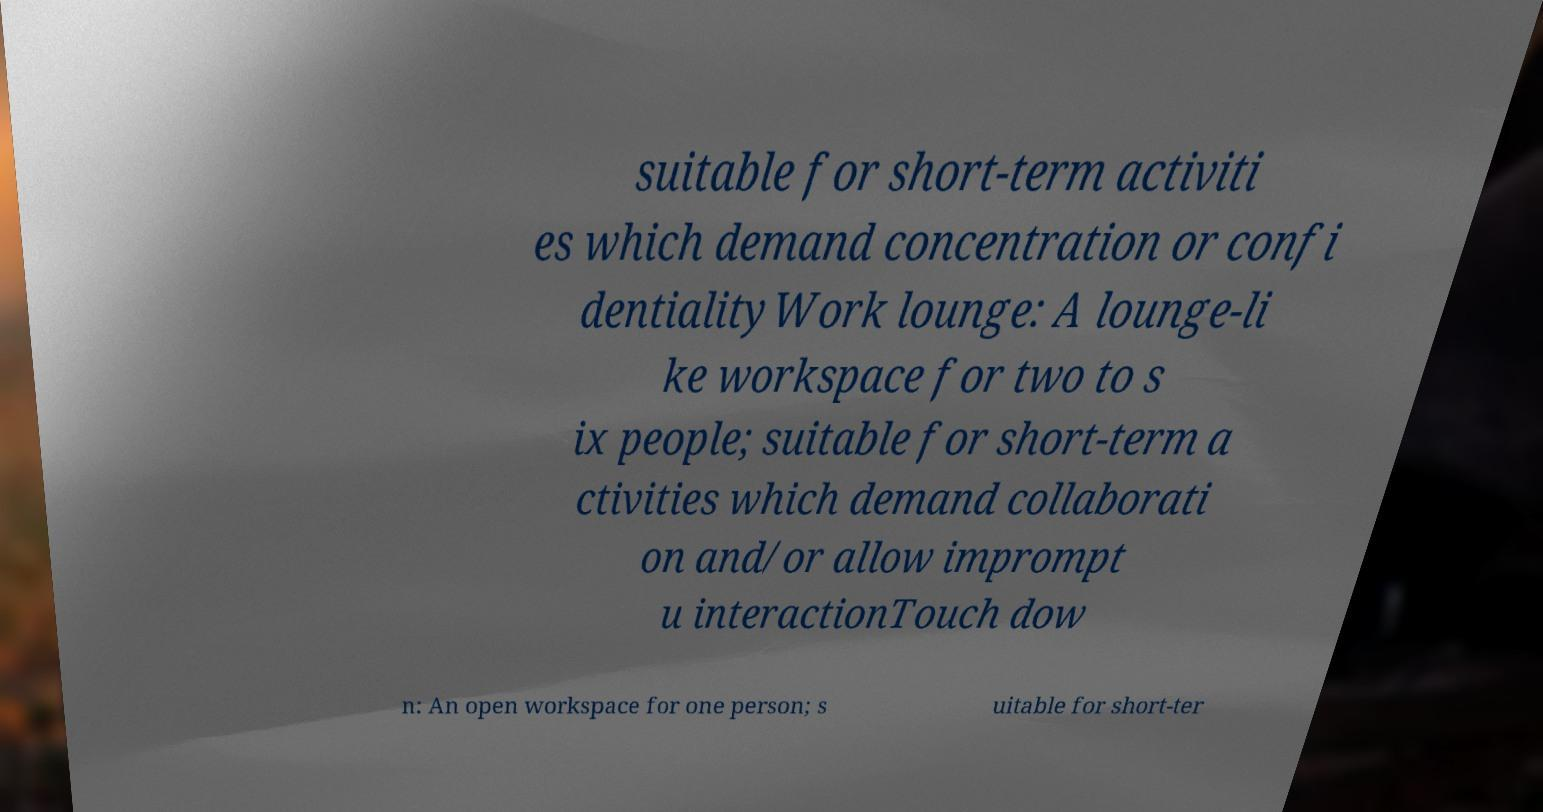Could you assist in decoding the text presented in this image and type it out clearly? suitable for short-term activiti es which demand concentration or confi dentialityWork lounge: A lounge-li ke workspace for two to s ix people; suitable for short-term a ctivities which demand collaborati on and/or allow imprompt u interactionTouch dow n: An open workspace for one person; s uitable for short-ter 